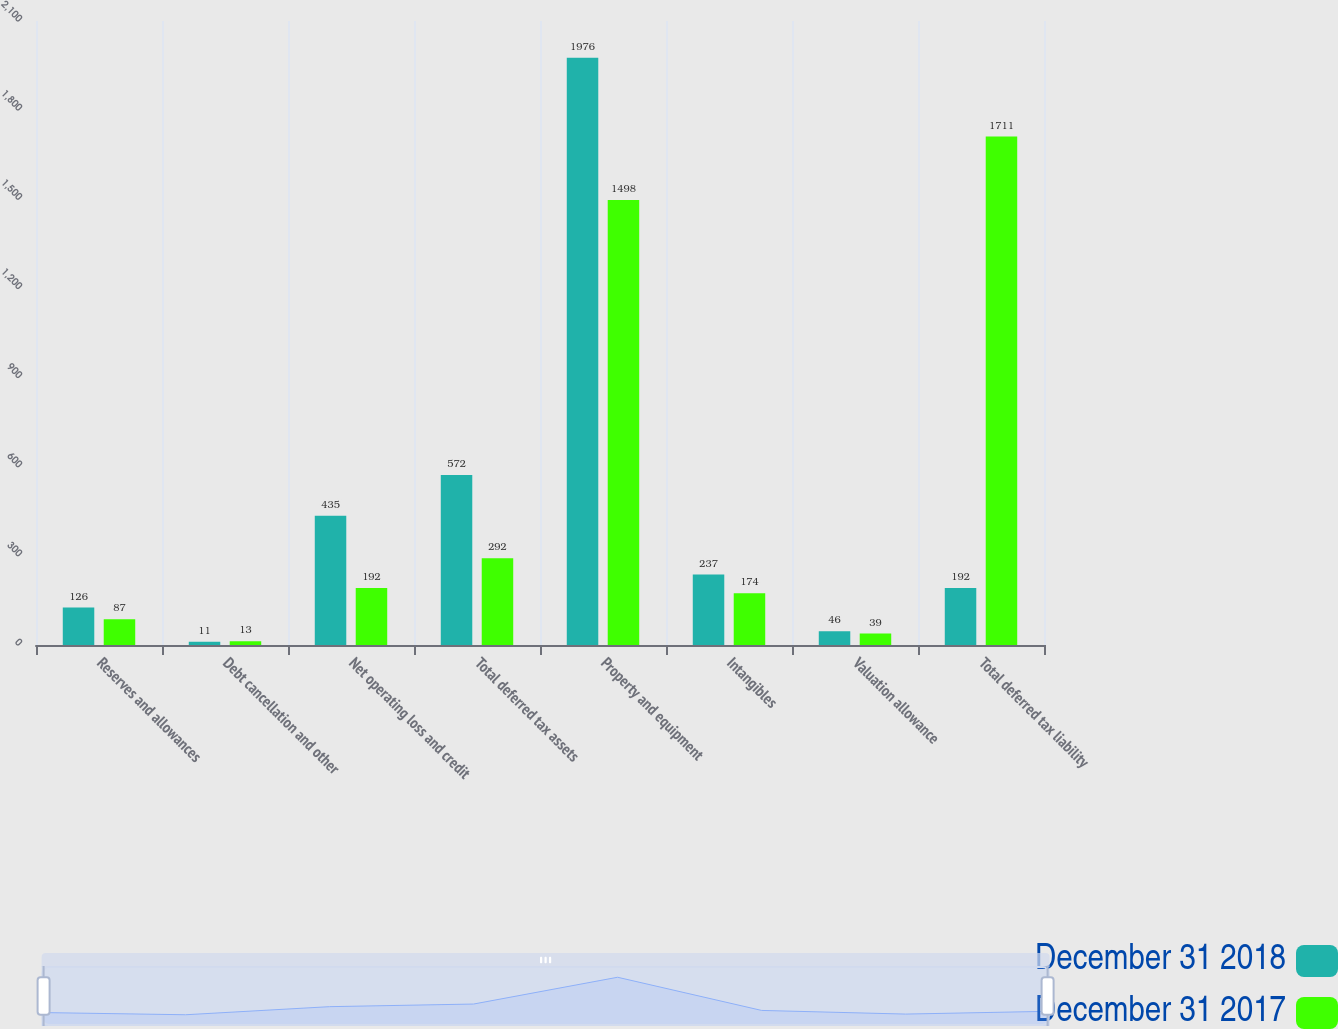Convert chart to OTSL. <chart><loc_0><loc_0><loc_500><loc_500><stacked_bar_chart><ecel><fcel>Reserves and allowances<fcel>Debt cancellation and other<fcel>Net operating loss and credit<fcel>Total deferred tax assets<fcel>Property and equipment<fcel>Intangibles<fcel>Valuation allowance<fcel>Total deferred tax liability<nl><fcel>December 31 2018<fcel>126<fcel>11<fcel>435<fcel>572<fcel>1976<fcel>237<fcel>46<fcel>192<nl><fcel>December 31 2017<fcel>87<fcel>13<fcel>192<fcel>292<fcel>1498<fcel>174<fcel>39<fcel>1711<nl></chart> 